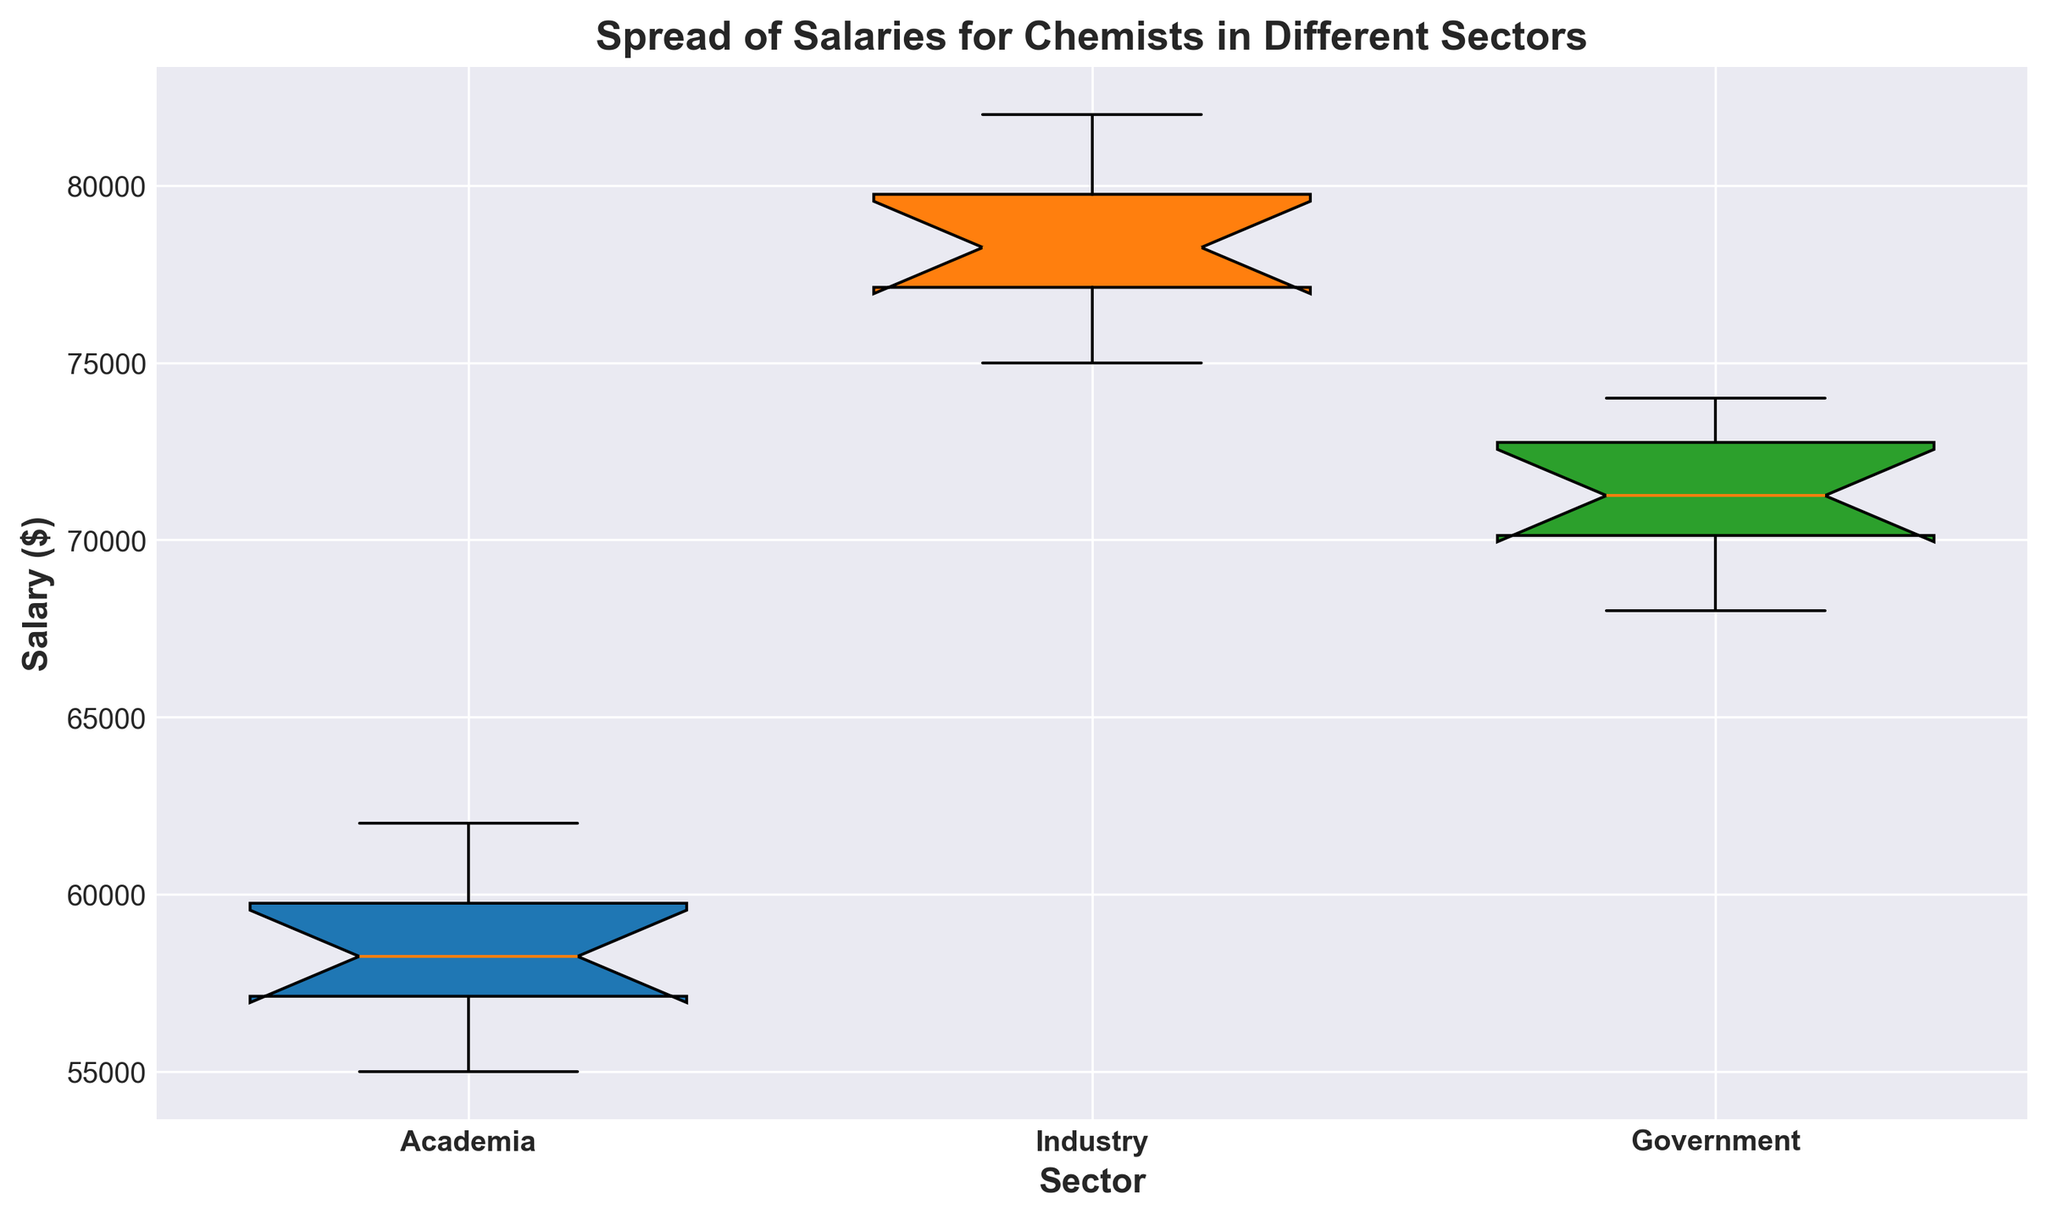What is the median salary in the academia sector? The median is found by ranking the data points and locating the middle value. In the academia sector, the median salary is the 5th and 6th values averaged due to an even number of data points.
Answer: $58000 Which sector has the highest median salary? Look at the boxplot's median line for each sector. The industrial sector has the highest median since its line is higher than those of academia and government.
Answer: Industry How does the range of salaries in academia compare to the range in industry? The range is the difference between the maximum and minimum values. For academia, it's $62000 - $55000 = $7000. For industry, it's $82000 - $75000 = $7000. Both sectors have the same range.
Answer: Equal What is the average salary in the government sector? Sum all government salaries and divide by the number of data points: ($68000+$70000+$73000+$71000+$72000+$69000+$73000+$74000+$70500+$71500)/10 = $71200
Answer: $71200 Which sector has the least variability in salaries? Variability can be assessed using the interquartile range (IQR). The IQR, which is the difference between the upper and lower quartiles, is smallest for government compared to academia and industry.
Answer: Government How does the third quartile salary in academia compare to the first quartile salary in industry? The third quartile (Q3) for academia, which is the top of the box, is around $60000. The first quartile (Q1) for industry, which is the bottom of the box, is around $76000. Q3 in academia is less than Q1 in industry.
Answer: Less What is the main difference between the salaries in government and industry sectors? Compare the median lines of both sectors. The median salary in the government sector is significantly lower than in the industry sector.
Answer: Industry has higher median What is the interquartile range (IQR) for the government sector? The IQR is the difference between the third quartile (Q3) and the first quartile (Q1). For the government sector, Q1 is about $70000 and Q3 is about $73000. IQR = $73000 - $70000 = $3000.
Answer: $3000 In terms of salary spread, which sector shows the broadest range, and what might this suggest about salary variability? The broader range indicates greater salary variability. By visually checking, the industry has a broader range from $75000 to $82000, suggesting higher variability.
Answer: Industry 